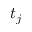<formula> <loc_0><loc_0><loc_500><loc_500>t _ { j }</formula> 